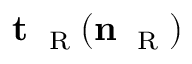<formula> <loc_0><loc_0><loc_500><loc_500>{ t } _ { R } ( { n } _ { R } )</formula> 